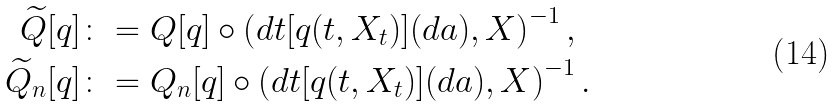Convert formula to latex. <formula><loc_0><loc_0><loc_500><loc_500>\widetilde { Q } [ q ] & \colon = Q [ q ] \circ \left ( d t [ q ( t , X _ { t } ) ] ( d a ) , X \right ) ^ { - 1 } , \\ \widetilde { Q } _ { n } [ q ] & \colon = Q _ { n } [ q ] \circ \left ( d t [ q ( t , X _ { t } ) ] ( d a ) , X \right ) ^ { - 1 } .</formula> 